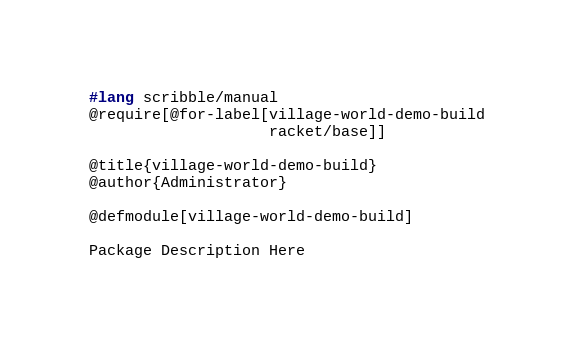Convert code to text. <code><loc_0><loc_0><loc_500><loc_500><_Racket_>#lang scribble/manual
@require[@for-label[village-world-demo-build
                    racket/base]]

@title{village-world-demo-build}
@author{Administrator}

@defmodule[village-world-demo-build]

Package Description Here
</code> 